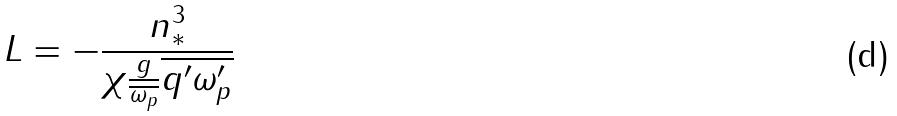<formula> <loc_0><loc_0><loc_500><loc_500>L = - \frac { n _ { * } ^ { 3 } } { \chi \frac { g } { \overline { \omega _ { p } } } \overline { q ^ { \prime } \omega _ { p } ^ { \prime } } }</formula> 